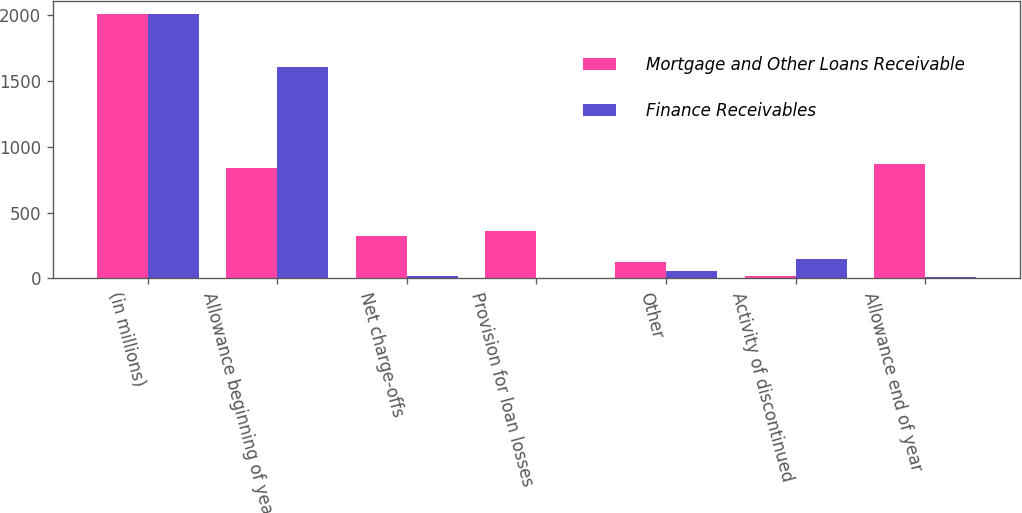Convert chart to OTSL. <chart><loc_0><loc_0><loc_500><loc_500><stacked_bar_chart><ecel><fcel>(in millions)<fcel>Allowance beginning of year<fcel>Net charge-offs<fcel>Provision for loan losses<fcel>Other<fcel>Activity of discontinued<fcel>Allowance end of year<nl><fcel>Mortgage and Other Loans Receivable<fcel>2010<fcel>838<fcel>326<fcel>363<fcel>122<fcel>18<fcel>867<nl><fcel>Finance Receivables<fcel>2010<fcel>1606<fcel>20<fcel>6<fcel>53<fcel>144<fcel>11<nl></chart> 